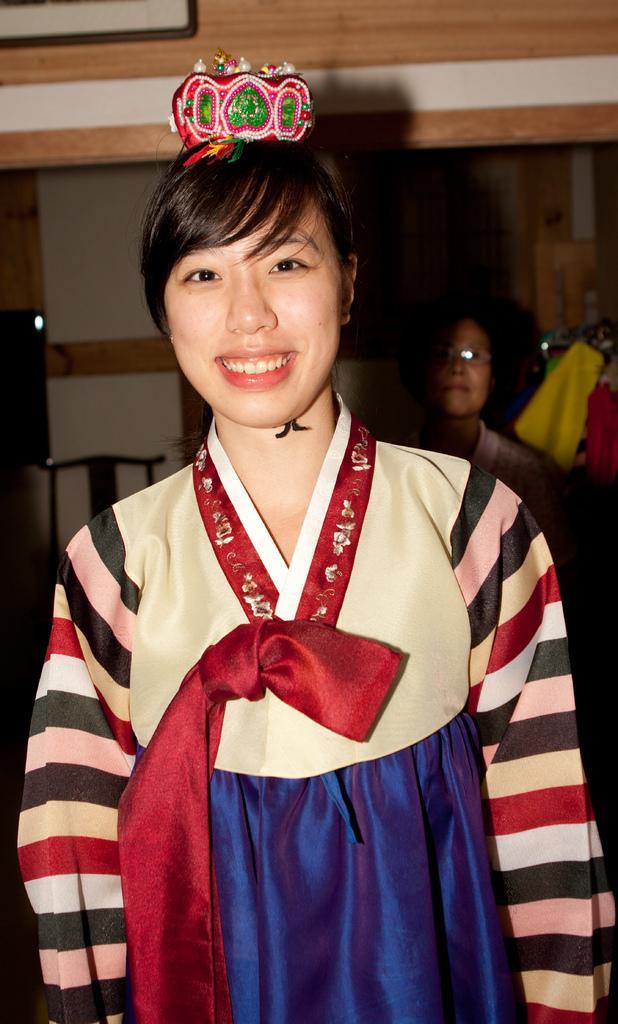Could you give a brief overview of what you see in this image? Here I can see a woman wearing costume, standing, smiling and giving pose for the picture. At the back there is another person. On the right side there are some clothes. In the background there is a wall. 